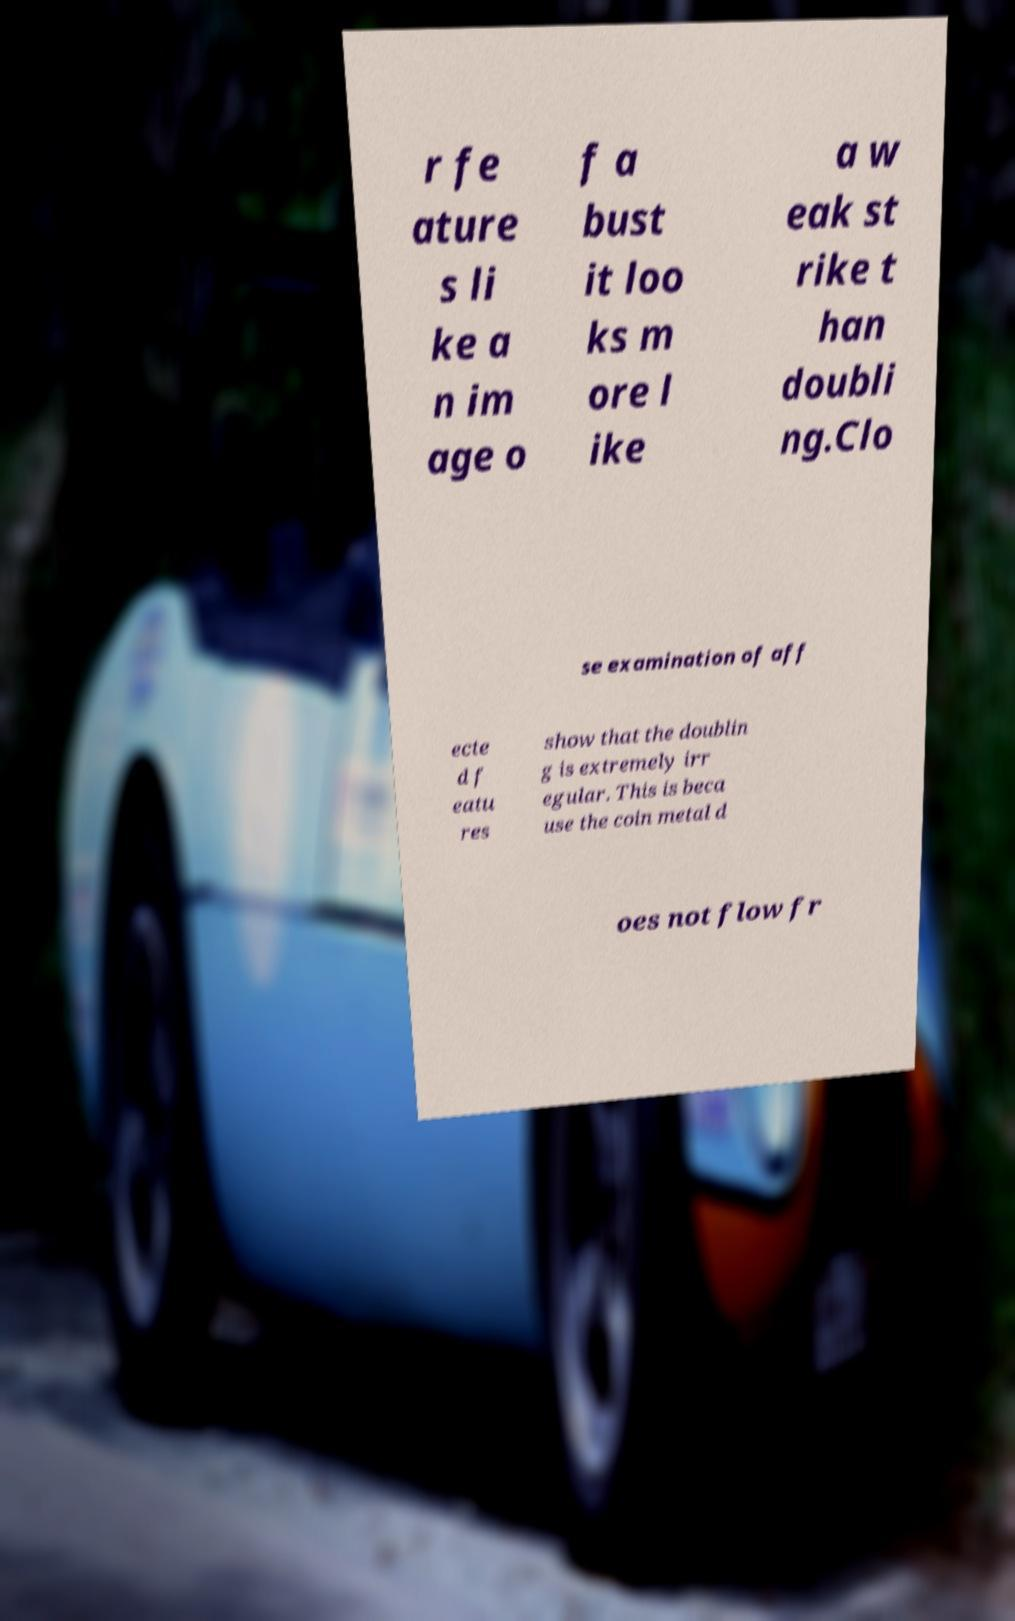I need the written content from this picture converted into text. Can you do that? r fe ature s li ke a n im age o f a bust it loo ks m ore l ike a w eak st rike t han doubli ng.Clo se examination of aff ecte d f eatu res show that the doublin g is extremely irr egular. This is beca use the coin metal d oes not flow fr 